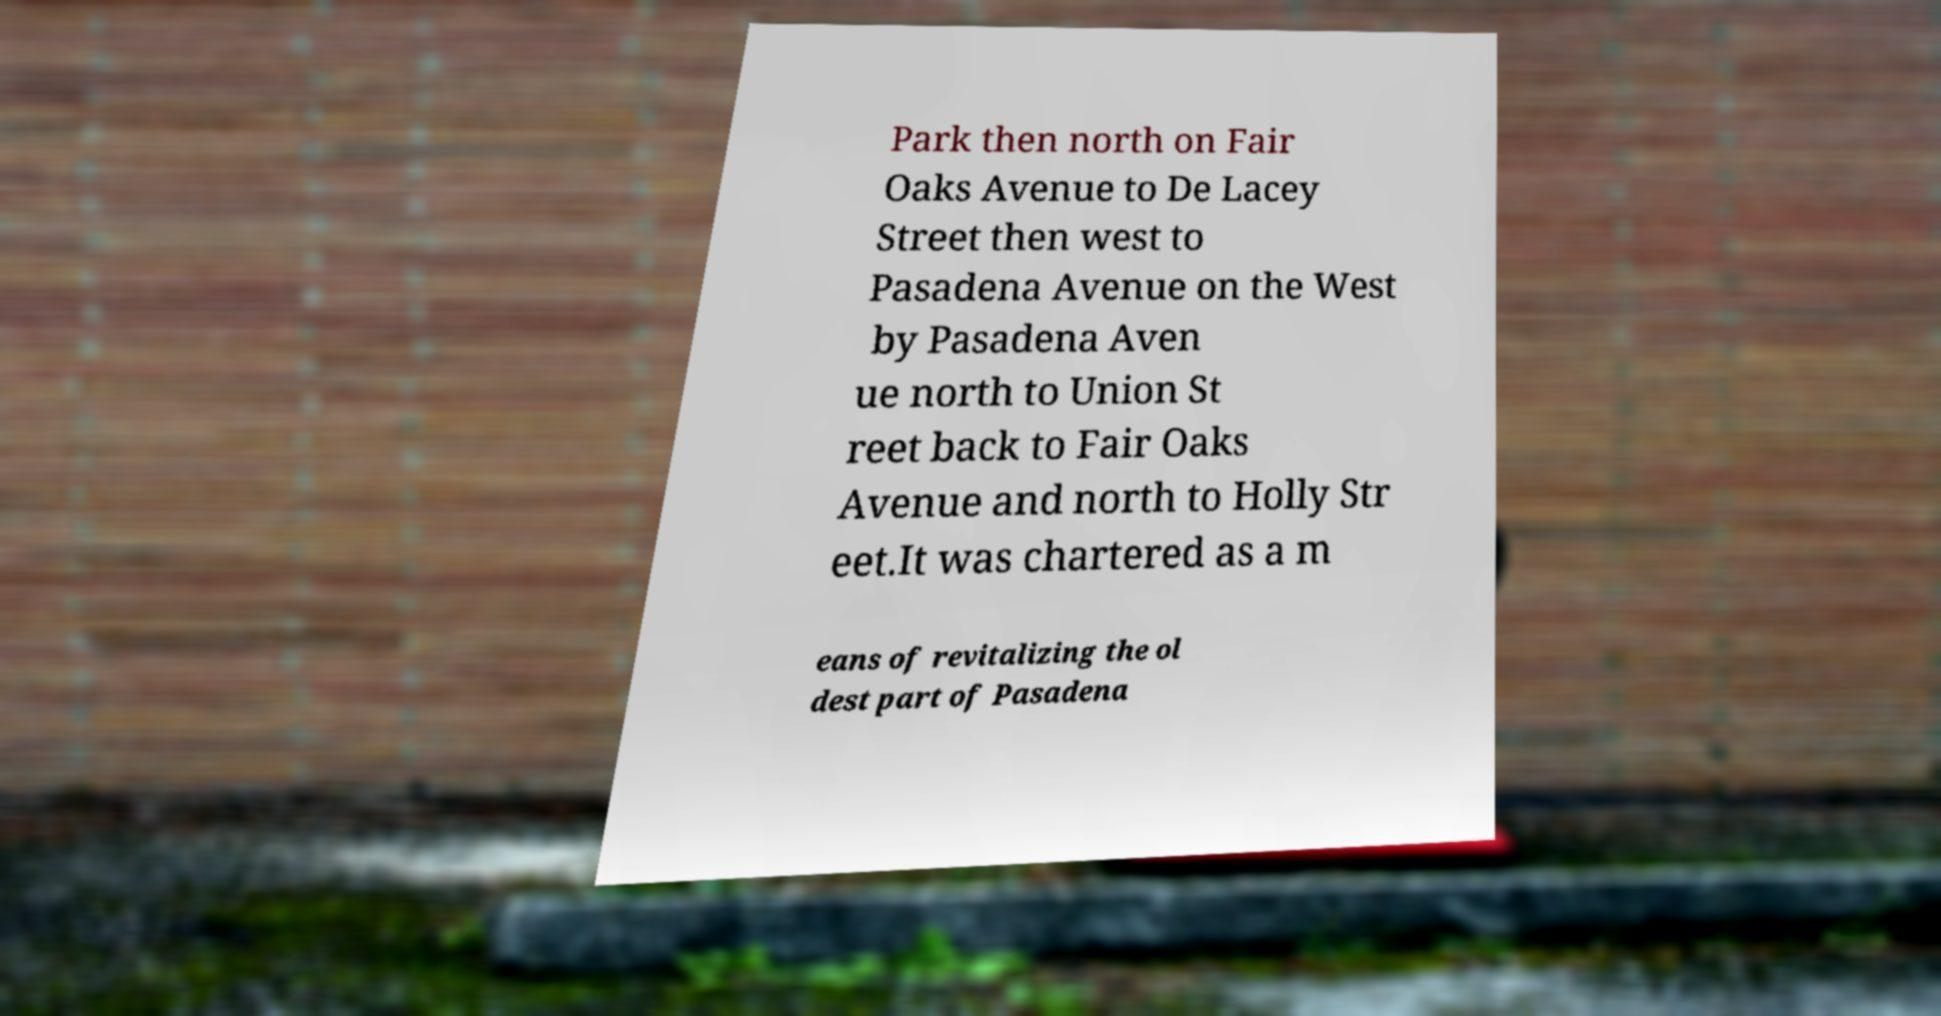Can you accurately transcribe the text from the provided image for me? Park then north on Fair Oaks Avenue to De Lacey Street then west to Pasadena Avenue on the West by Pasadena Aven ue north to Union St reet back to Fair Oaks Avenue and north to Holly Str eet.It was chartered as a m eans of revitalizing the ol dest part of Pasadena 